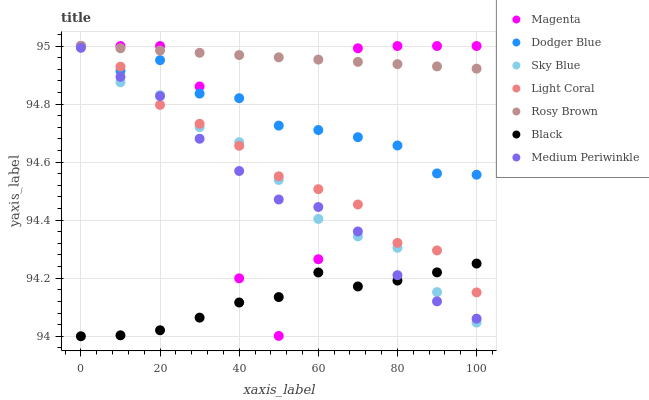Does Black have the minimum area under the curve?
Answer yes or no. Yes. Does Rosy Brown have the maximum area under the curve?
Answer yes or no. Yes. Does Medium Periwinkle have the minimum area under the curve?
Answer yes or no. No. Does Medium Periwinkle have the maximum area under the curve?
Answer yes or no. No. Is Rosy Brown the smoothest?
Answer yes or no. Yes. Is Magenta the roughest?
Answer yes or no. Yes. Is Medium Periwinkle the smoothest?
Answer yes or no. No. Is Medium Periwinkle the roughest?
Answer yes or no. No. Does Black have the lowest value?
Answer yes or no. Yes. Does Medium Periwinkle have the lowest value?
Answer yes or no. No. Does Magenta have the highest value?
Answer yes or no. Yes. Does Medium Periwinkle have the highest value?
Answer yes or no. No. Is Medium Periwinkle less than Rosy Brown?
Answer yes or no. Yes. Is Dodger Blue greater than Black?
Answer yes or no. Yes. Does Light Coral intersect Rosy Brown?
Answer yes or no. Yes. Is Light Coral less than Rosy Brown?
Answer yes or no. No. Is Light Coral greater than Rosy Brown?
Answer yes or no. No. Does Medium Periwinkle intersect Rosy Brown?
Answer yes or no. No. 